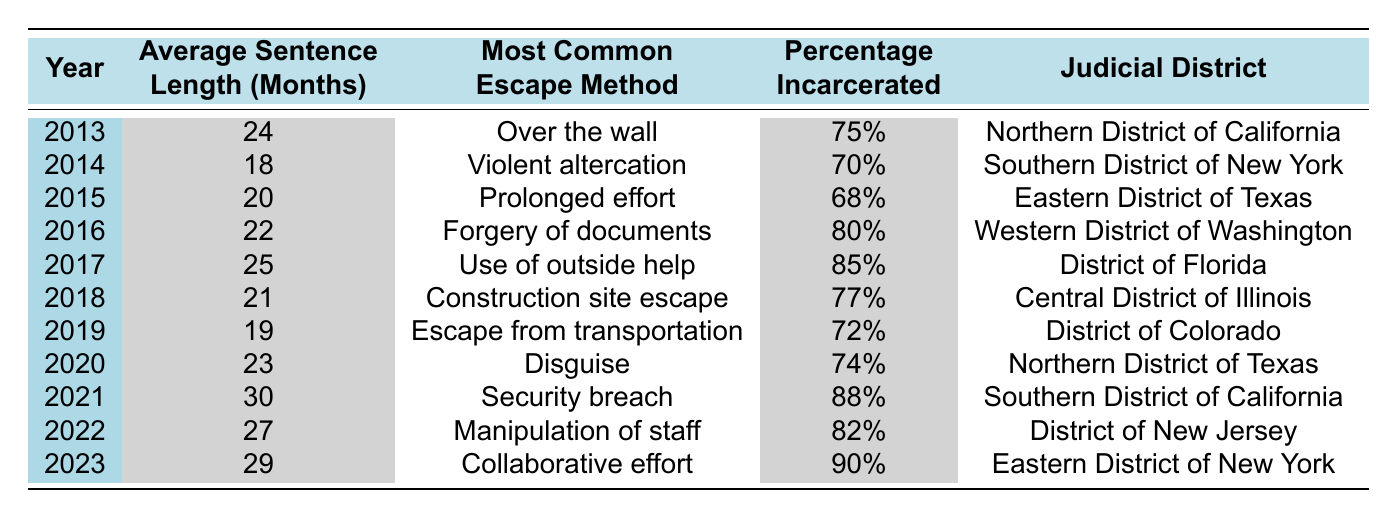What was the average sentence length for escape charges in 2021? The table shows that the average sentence length for 2021 is 30 months.
Answer: 30 months Which year had the highest percentage incarcerated for escape charges? Looking through the percentage incarcerated column, 2023 has the highest percentage at 90%.
Answer: 90% How many years had an average sentence length greater than 25 months? The years with average sentence lengths greater than 25 months are 2017 (25), 2021 (30), 2022 (27), and 2023 (29). Thus, there are 4 years.
Answer: 4 years True or False: The most common escape method in 2016 was "Disguise." Checking the most common escape method for 2016 in the table, it was "Forgery of documents," so the statement is false.
Answer: False What is the average sentence length for the years 2013 to 2015? The average sentence lengths for these years are 24 months (2013), 18 months (2014), and 20 months (2015). Adding these gives 62 months. Dividing by 3 (the number of years) gives an average of 20.67 months, rounded to 21.
Answer: 21 months In which judicial district was the least common escape method "Prolonged effort" recorded? The year where "Prolonged effort" was the most common escape method is 2015, which is categorized under the Eastern District of Texas.
Answer: Eastern District of Texas What percentage incarcerated was consistent between 2014 and 2019? Reviewing the percentage incarcerated for each year from 2014 (70%), 2015 (68%), 2016 (80%), 2017 (85%), 2018 (77%), and 2019 (72%), there are no years with consistent percentages during these years.
Answer: None Which year shows a trend of increasing average sentence length from the previous years? Comparing the average sentence lengths year by year, from 2018 (21) to 2019 (19) is a decrease, then from 2020 (23), 2021 (30), 2022 (27), and 2023 (29) show continuous increases. Thus, the trend starts from 2020 onwards.
Answer: 2020 onwards What was the most common escape method in the year with the lowest average sentence length? The year with the lowest average sentence length is 2014, which corresponds to the most common escape method being "Violent altercation."
Answer: Violent altercation 